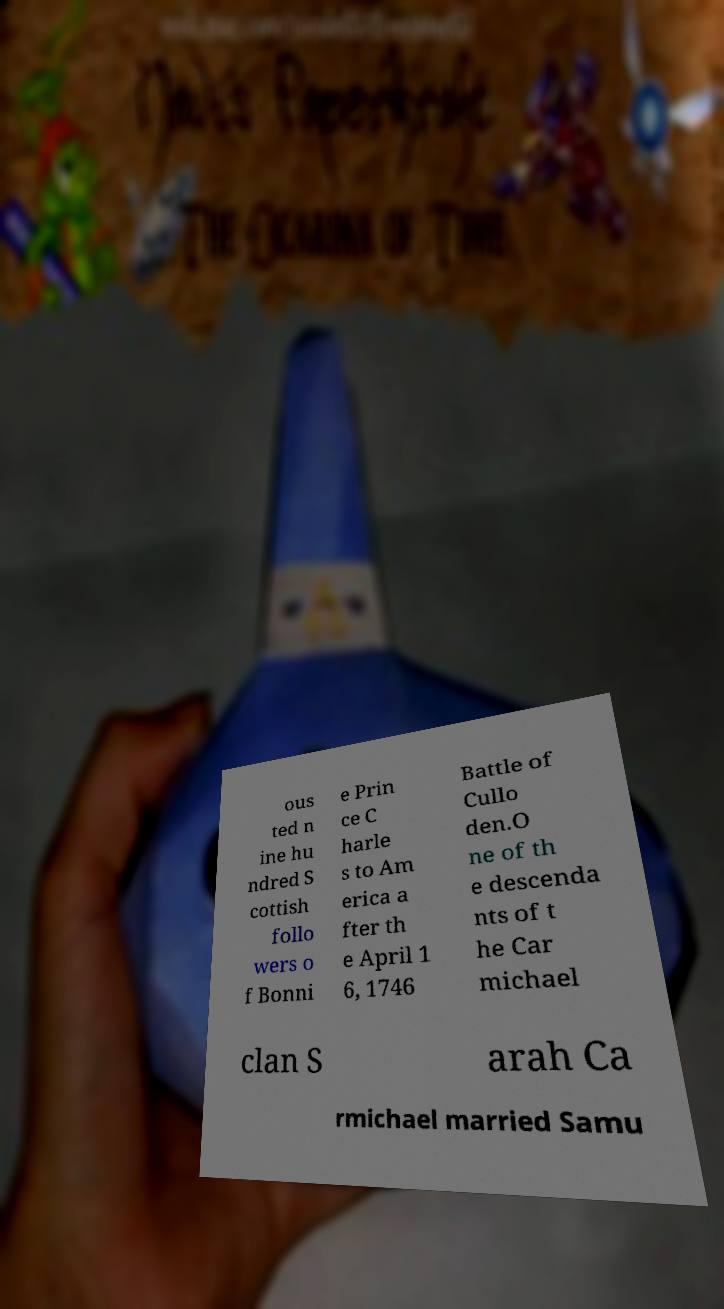I need the written content from this picture converted into text. Can you do that? ous ted n ine hu ndred S cottish follo wers o f Bonni e Prin ce C harle s to Am erica a fter th e April 1 6, 1746 Battle of Cullo den.O ne of th e descenda nts of t he Car michael clan S arah Ca rmichael married Samu 